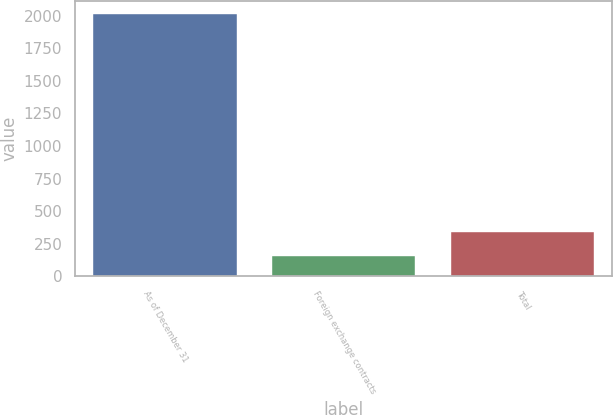Convert chart to OTSL. <chart><loc_0><loc_0><loc_500><loc_500><bar_chart><fcel>As of December 31<fcel>Foreign exchange contracts<fcel>Total<nl><fcel>2010<fcel>157<fcel>342.3<nl></chart> 